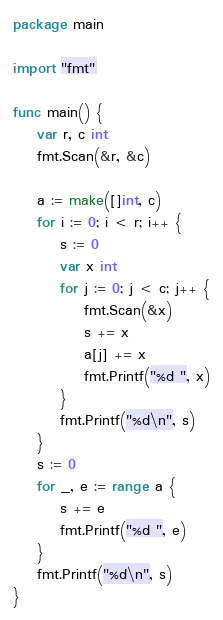Convert code to text. <code><loc_0><loc_0><loc_500><loc_500><_Go_>package main

import "fmt"

func main() {
	var r, c int
	fmt.Scan(&r, &c)

	a := make([]int, c)
	for i := 0; i < r; i++ {
		s := 0
		var x int
		for j := 0; j < c; j++ {
			fmt.Scan(&x)
			s += x
			a[j] += x
			fmt.Printf("%d ", x)
		}
		fmt.Printf("%d\n", s)
	}
	s := 0
	for _, e := range a {
		s += e
		fmt.Printf("%d ", e)
	}
	fmt.Printf("%d\n", s)
}

</code> 